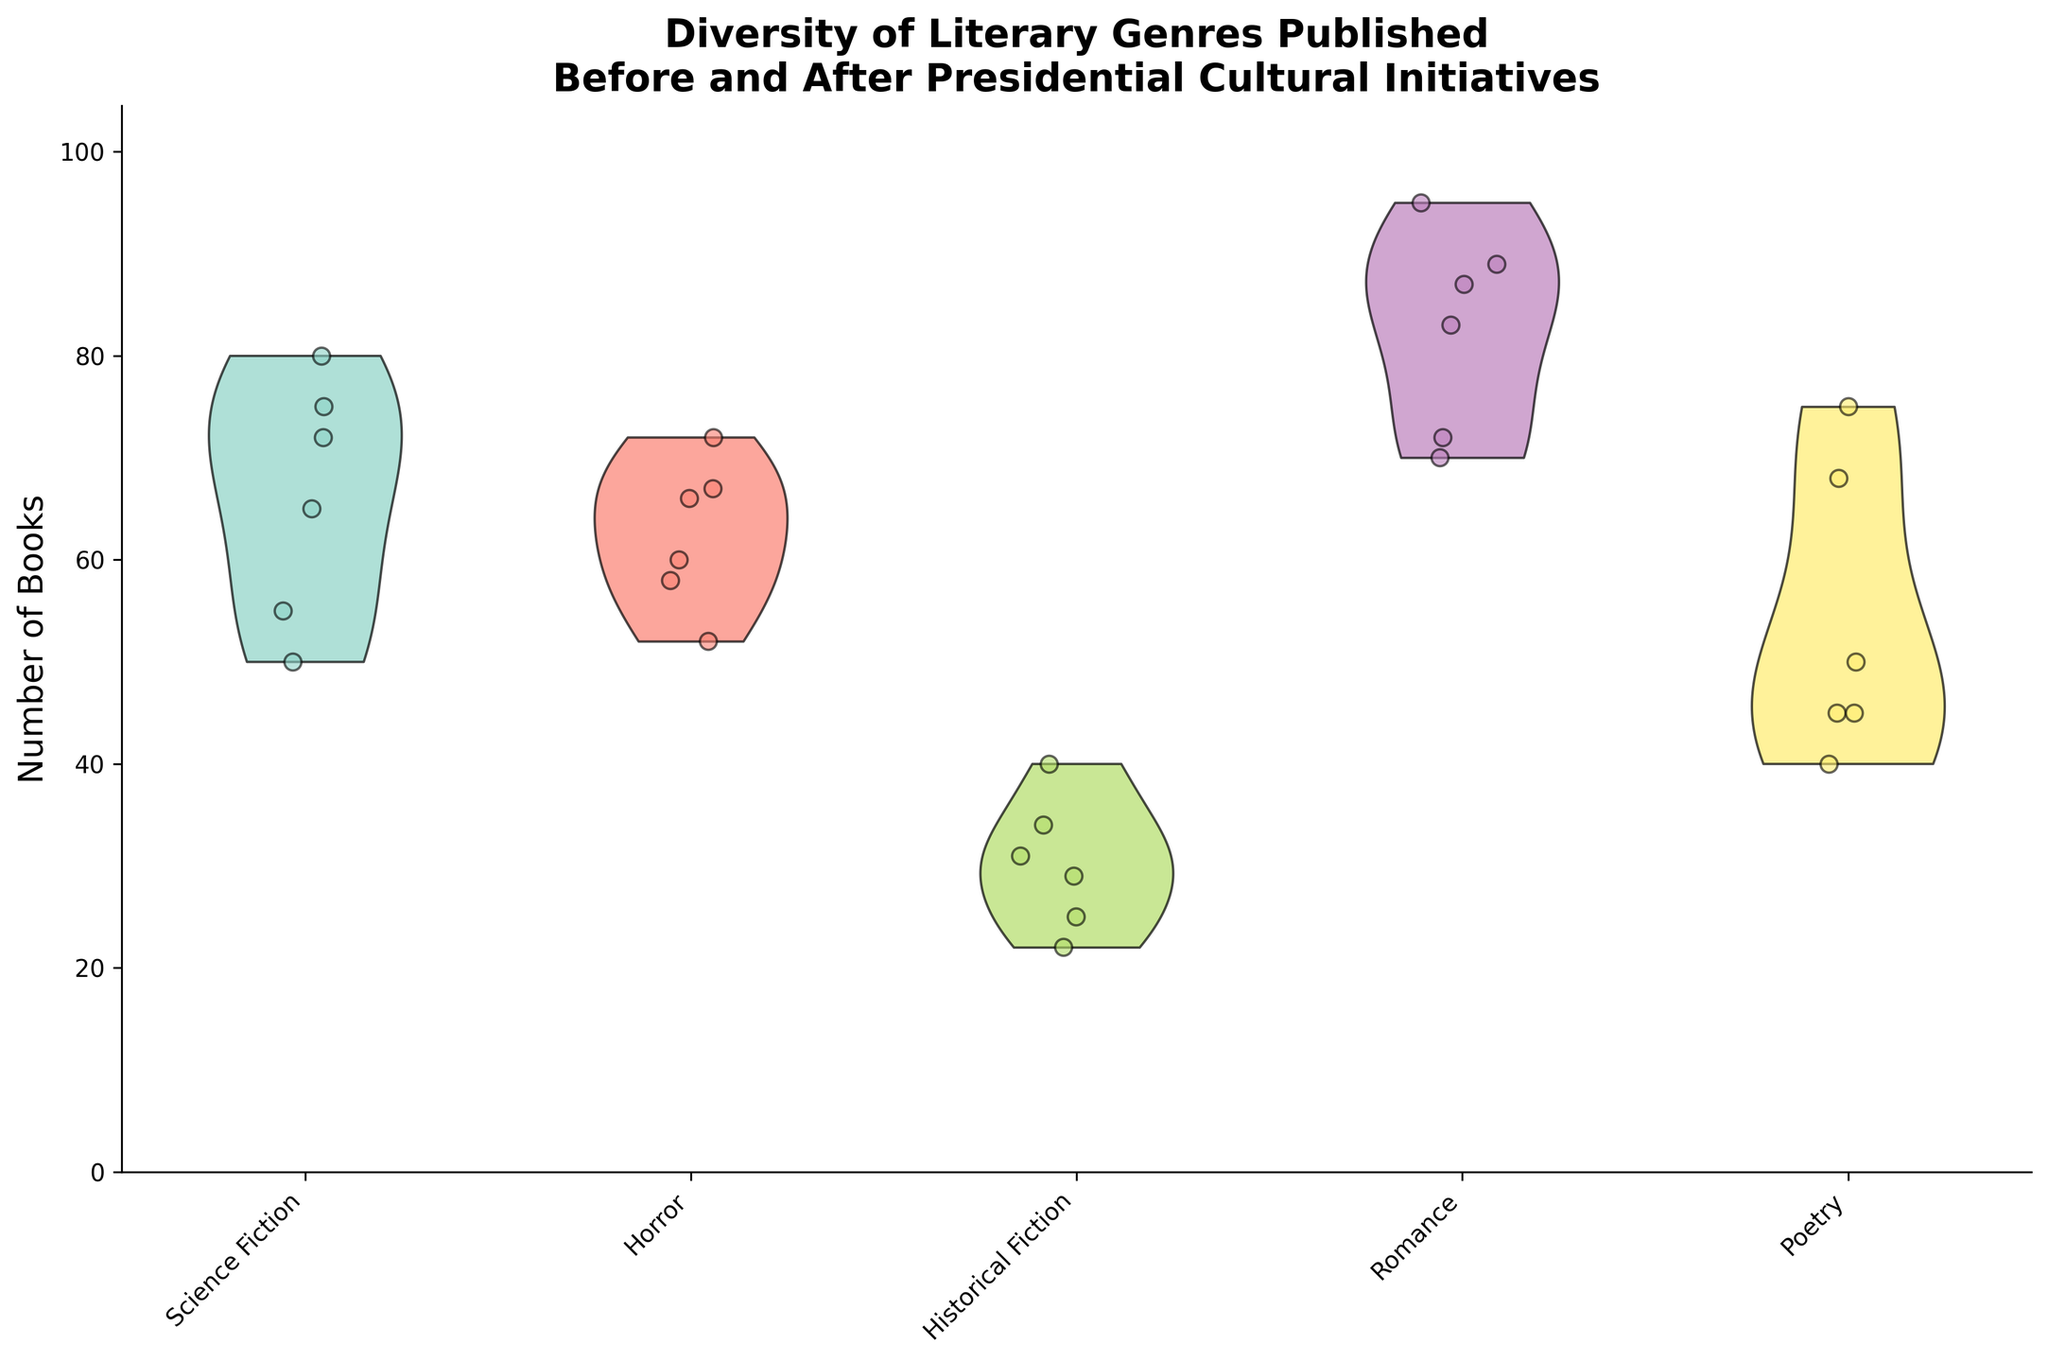What is the title of the figure? The title is typically placed at the top of the figure. It is a short description of what the figure depicts. Here, the title is "Diversity of Literary Genres Published Before and After Presidential Cultural Initiatives."
Answer: Diversity of Literary Genres Published Before and After Presidential Cultural Initiatives Which genre shows the highest number of books published in 2000? To determine this, look at the spread and density of data points within each violin plot for the year 2000. Identify the peak density points for each genre and see which one reaches the highest value. In this case, it's the Romance genre.
Answer: Romance Are there more books published in the Science Fiction genre in 2000 or 2018? By comparing the positions and density of jittered points in violin plots for Science Fiction across these years, note the higher concentration of points in 2000 compared to 2018.
Answer: 2000 Which genre shows the most significant increase in books published from 1999 to 2000? Observe each genre's violin plots for 1999 and 2000. Note the general shape and density of data points. Romance shows a visible increase in the number of books.
Answer: Romance Which genre experienced the smallest change in the number of books published across presidential initiatives? To find this, check the violin plots for each genre across different presidential initiatives. Compare how similar the distributions are across years. Poetry shows relatively small changes.
Answer: Poetry Is there a common trend for Horror genre books published under different presidents? Examine the Horror violin plots under Bill Clinton, Barack Obama, and Donald Trump. Identify general trends, whether increasing, decreasing, or stable. Horror shows an increasing trend across these years.
Answer: Increasing How does the distribution of books in the Historical Fiction genre look under Barack Obama's initiative? Check the violin plot and jittered points for Historical Fiction during Barack Obama’s initiative. Note the density and spread of data points to describe the distribution. It usually has a few data points closely packed around lower values.
Answer: Low and tightly packed What can be inferred from the violin plot about Science Fiction books published in 2017 compared to 2009? Compare the density and peak points of the violin plots for Science Fiction in 2017 and 2009. Note that 2017 shows a lower peak compared to 2009, indicating fewer books published in 2017.
Answer: Fewer books in 2017 Which genre has the most evenly distributed number of books across all initiatives? Look for the genre with violin plots displaying a consistent spread of data points across the different years. Romance has one of the more evenly spread distributions.
Answer: Romance 